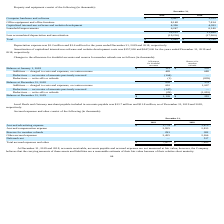From Travelzoo's financial document, What is the depreciation expense for 2019 and 2018 respectively? The document shows two values: $1.2 million and $1.6 million. From the document: "Depreciation expense was $1.2 million and $1.6 million for the years ended December 31, 2019 and 2018, respectively. Depreciation expense was $1.2 mil..." Also, What is the amount of computer hardware and software for 2019 and 2018 respectively? The document shows two values: $3,427 and $3,353 (in thousands). From the document: "Computer hardware and software $ 3,427 $ 3,353 Computer hardware and software $ 3,427 $ 3,353..." Also, What is the amount of office equipment and office furniture for 2019 and 2018 respectively? The document shows two values: 8,148 and 7,814 (in thousands). From the document: "Office equipment and office furniture 8,148 7,814 Office equipment and office furniture 8,148 7,814..." Also, can you calculate: What is the change in the amount of computer hardware and software between 2018 and 2019? Based on the calculation: 3,427-3,353, the result is 74 (in thousands). This is based on the information: "Computer hardware and software $ 3,427 $ 3,353 Computer hardware and software $ 3,427 $ 3,353..." The key data points involved are: 3,353, 3,427. Also, can you calculate: What is the average of the total property and equipment for 2018 and 2019? To answer this question, I need to perform calculations using the financial data. The calculation is: (2,982+ 3,790)/2, which equals 3386 (in thousands). This is based on the information: "Total $ 2,982 $ 3,790 Total $ 2,982 $ 3,790..." The key data points involved are: 2,982, 3,790. Also, can you calculate: What is the percentage change in the leasehold improvements amount from 2018 to 2019? To answer this question, I need to perform calculations using the financial data. The calculation is: (6,247-6,140)/6,140, which equals 1.74 (percentage). This is based on the information: "Leasehold improvements 6,247 6,140 Leasehold improvements 6,247 6,140..." The key data points involved are: 6,140, 6,247. 